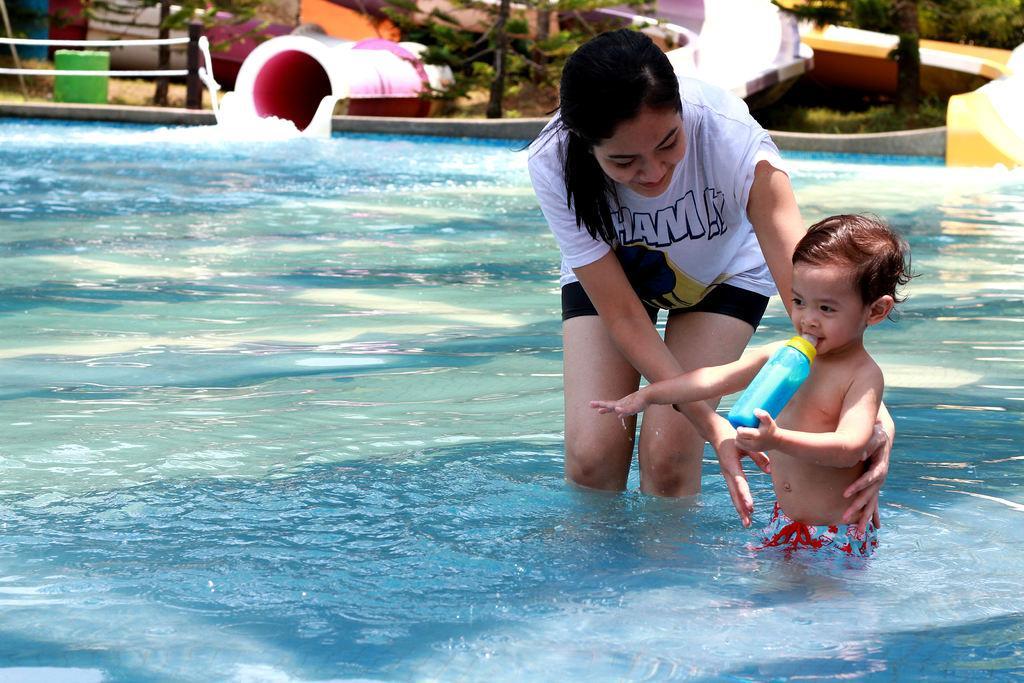In one or two sentences, can you explain what this image depicts? In this picture there is a woman wearing white color t- shirt, standing in the swimming pool. Beside there is a small boy standing in the pool. Behind there is a pipe and some plants. 